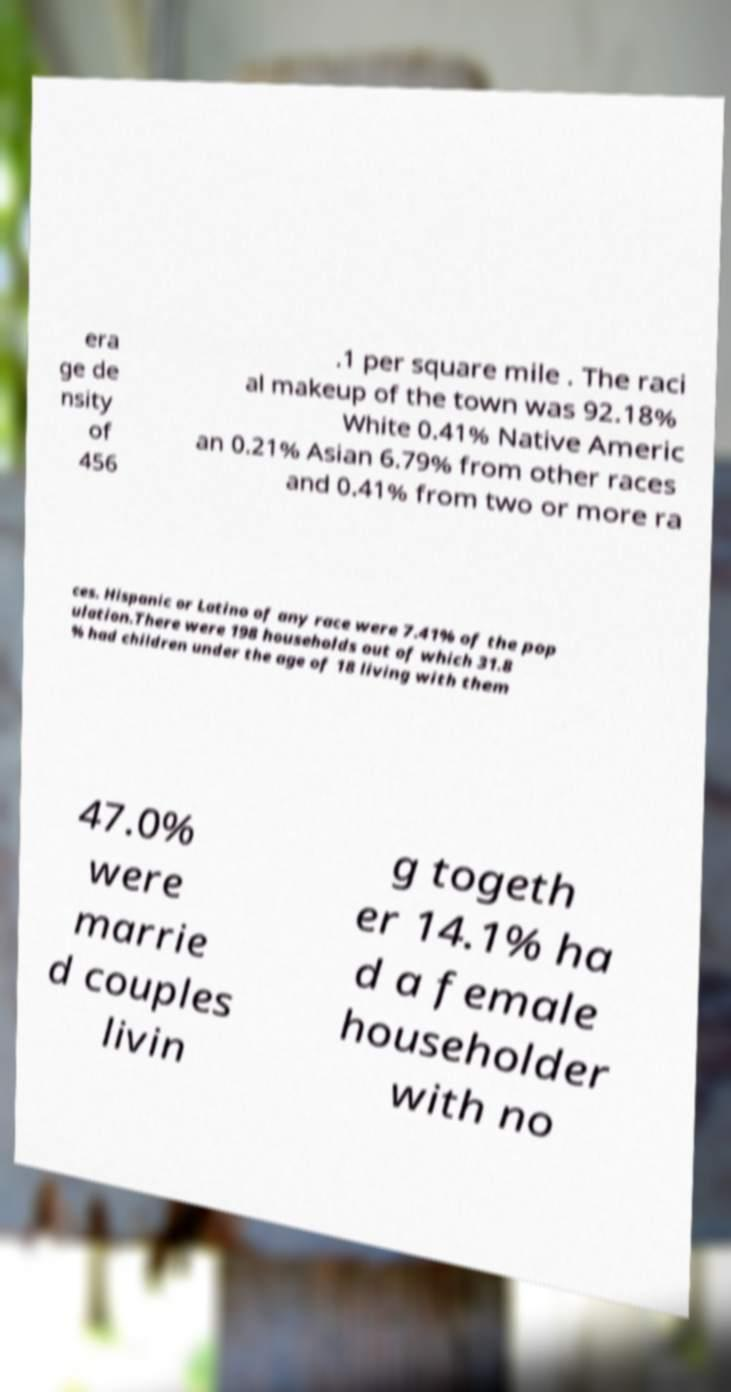For documentation purposes, I need the text within this image transcribed. Could you provide that? era ge de nsity of 456 .1 per square mile . The raci al makeup of the town was 92.18% White 0.41% Native Americ an 0.21% Asian 6.79% from other races and 0.41% from two or more ra ces. Hispanic or Latino of any race were 7.41% of the pop ulation.There were 198 households out of which 31.8 % had children under the age of 18 living with them 47.0% were marrie d couples livin g togeth er 14.1% ha d a female householder with no 